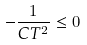Convert formula to latex. <formula><loc_0><loc_0><loc_500><loc_500>- \frac { 1 } { C T ^ { 2 } } \leq 0</formula> 